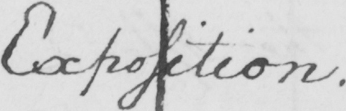Please provide the text content of this handwritten line. Exposition . 